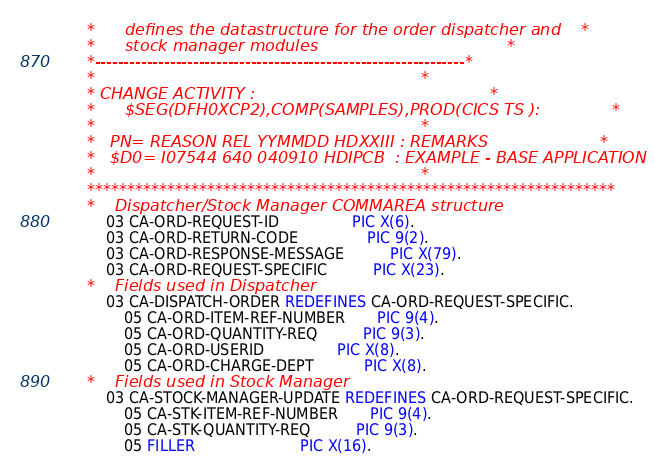<code> <loc_0><loc_0><loc_500><loc_500><_COBOL_>      *      defines the datastructure for the order dispatcher and    *
      *      stock manager modules                                     *
      *----------------------------------------------------------------*
      *                                                                *
      * CHANGE ACTIVITY :                                              *
      *      $SEG(DFH0XCP2),COMP(SAMPLES),PROD(CICS TS ):              *
      *                                                                *
      *   PN= REASON REL YYMMDD HDXXIII : REMARKS                      *
      *   $D0= I07544 640 040910 HDIPCB  : EXAMPLE - BASE APPLICATION  *
      *                                                                *
      ******************************************************************
      *    Dispatcher/Stock Manager COMMAREA structure
           03 CA-ORD-REQUEST-ID                PIC X(6).
           03 CA-ORD-RETURN-CODE               PIC 9(2).
           03 CA-ORD-RESPONSE-MESSAGE          PIC X(79).
           03 CA-ORD-REQUEST-SPECIFIC          PIC X(23).
      *    Fields used in Dispatcher
           03 CA-DISPATCH-ORDER REDEFINES CA-ORD-REQUEST-SPECIFIC.
               05 CA-ORD-ITEM-REF-NUMBER       PIC 9(4).
               05 CA-ORD-QUANTITY-REQ          PIC 9(3).
               05 CA-ORD-USERID                PIC X(8).
               05 CA-ORD-CHARGE-DEPT           PIC X(8).
      *    Fields used in Stock Manager
           03 CA-STOCK-MANAGER-UPDATE REDEFINES CA-ORD-REQUEST-SPECIFIC.
               05 CA-STK-ITEM-REF-NUMBER       PIC 9(4).
               05 CA-STK-QUANTITY-REQ          PIC 9(3).
               05 FILLER                       PIC X(16).
</code> 